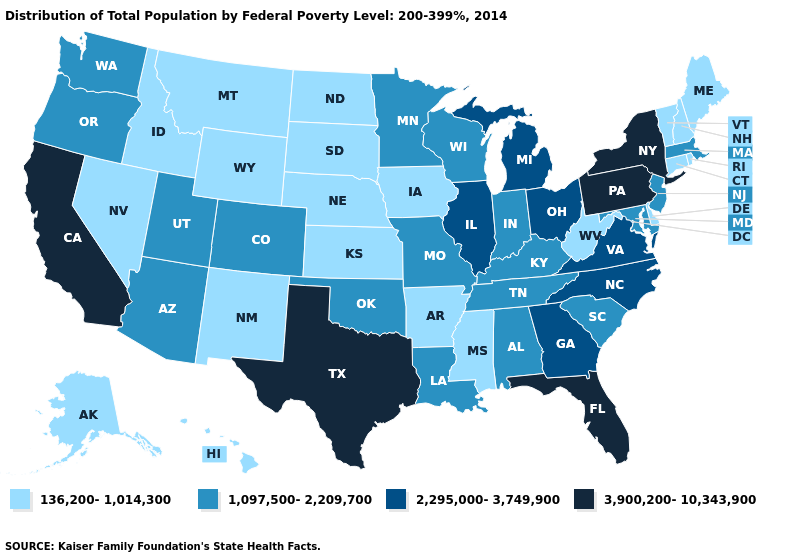What is the highest value in states that border Pennsylvania?
Be succinct. 3,900,200-10,343,900. What is the value of West Virginia?
Short answer required. 136,200-1,014,300. Name the states that have a value in the range 136,200-1,014,300?
Be succinct. Alaska, Arkansas, Connecticut, Delaware, Hawaii, Idaho, Iowa, Kansas, Maine, Mississippi, Montana, Nebraska, Nevada, New Hampshire, New Mexico, North Dakota, Rhode Island, South Dakota, Vermont, West Virginia, Wyoming. Among the states that border Maine , which have the highest value?
Give a very brief answer. New Hampshire. What is the value of Missouri?
Short answer required. 1,097,500-2,209,700. What is the value of Florida?
Give a very brief answer. 3,900,200-10,343,900. What is the value of Michigan?
Concise answer only. 2,295,000-3,749,900. Among the states that border California , does Nevada have the highest value?
Keep it brief. No. Name the states that have a value in the range 136,200-1,014,300?
Concise answer only. Alaska, Arkansas, Connecticut, Delaware, Hawaii, Idaho, Iowa, Kansas, Maine, Mississippi, Montana, Nebraska, Nevada, New Hampshire, New Mexico, North Dakota, Rhode Island, South Dakota, Vermont, West Virginia, Wyoming. What is the value of New Mexico?
Quick response, please. 136,200-1,014,300. What is the value of Pennsylvania?
Answer briefly. 3,900,200-10,343,900. Name the states that have a value in the range 1,097,500-2,209,700?
Write a very short answer. Alabama, Arizona, Colorado, Indiana, Kentucky, Louisiana, Maryland, Massachusetts, Minnesota, Missouri, New Jersey, Oklahoma, Oregon, South Carolina, Tennessee, Utah, Washington, Wisconsin. What is the lowest value in the Northeast?
Write a very short answer. 136,200-1,014,300. What is the value of Michigan?
Give a very brief answer. 2,295,000-3,749,900. Does New Hampshire have the lowest value in the Northeast?
Answer briefly. Yes. 